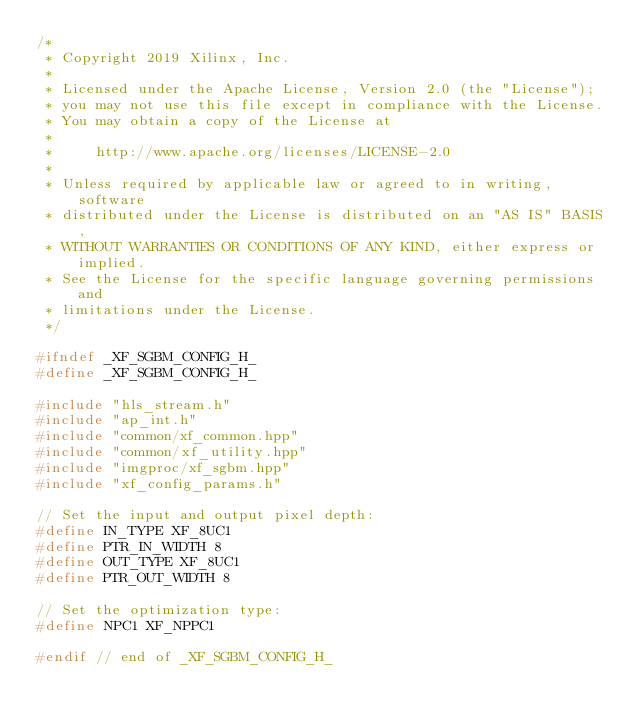Convert code to text. <code><loc_0><loc_0><loc_500><loc_500><_C_>/*
 * Copyright 2019 Xilinx, Inc.
 *
 * Licensed under the Apache License, Version 2.0 (the "License");
 * you may not use this file except in compliance with the License.
 * You may obtain a copy of the License at
 *
 *     http://www.apache.org/licenses/LICENSE-2.0
 *
 * Unless required by applicable law or agreed to in writing, software
 * distributed under the License is distributed on an "AS IS" BASIS,
 * WITHOUT WARRANTIES OR CONDITIONS OF ANY KIND, either express or implied.
 * See the License for the specific language governing permissions and
 * limitations under the License.
 */

#ifndef _XF_SGBM_CONFIG_H_
#define _XF_SGBM_CONFIG_H_

#include "hls_stream.h"
#include "ap_int.h"
#include "common/xf_common.hpp"
#include "common/xf_utility.hpp"
#include "imgproc/xf_sgbm.hpp"
#include "xf_config_params.h"

// Set the input and output pixel depth:
#define IN_TYPE XF_8UC1
#define PTR_IN_WIDTH 8
#define OUT_TYPE XF_8UC1
#define PTR_OUT_WIDTH 8

// Set the optimization type:
#define NPC1 XF_NPPC1

#endif // end of _XF_SGBM_CONFIG_H_
</code> 